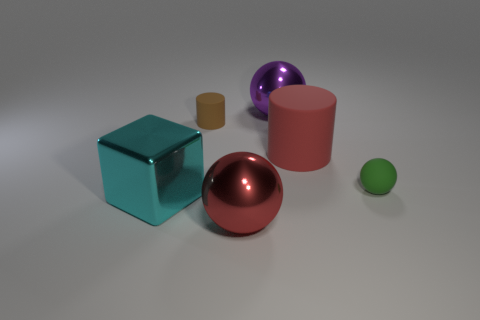Subtract all small rubber balls. How many balls are left? 2 Add 1 big matte cylinders. How many objects exist? 7 Subtract all red balls. How many balls are left? 2 Subtract all cylinders. How many objects are left? 4 Subtract 1 cylinders. How many cylinders are left? 1 Subtract all large shiny things. Subtract all gray rubber cylinders. How many objects are left? 3 Add 6 tiny green objects. How many tiny green objects are left? 7 Add 3 tiny green matte objects. How many tiny green matte objects exist? 4 Subtract 0 brown balls. How many objects are left? 6 Subtract all yellow cylinders. Subtract all brown blocks. How many cylinders are left? 2 